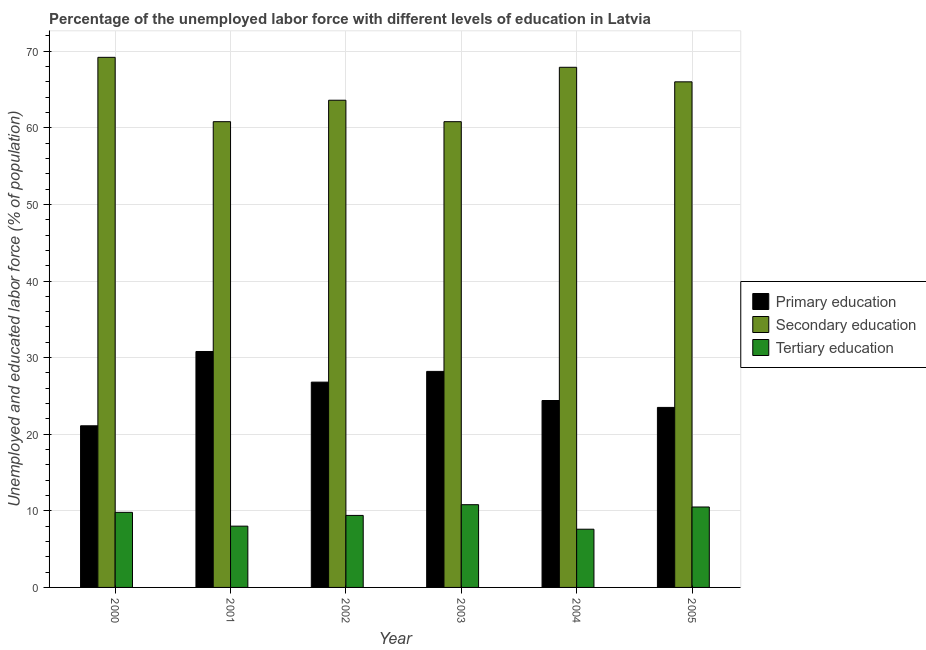How many different coloured bars are there?
Ensure brevity in your answer.  3. How many groups of bars are there?
Offer a very short reply. 6. Are the number of bars per tick equal to the number of legend labels?
Keep it short and to the point. Yes. In how many cases, is the number of bars for a given year not equal to the number of legend labels?
Give a very brief answer. 0. What is the percentage of labor force who received tertiary education in 2004?
Keep it short and to the point. 7.6. Across all years, what is the maximum percentage of labor force who received secondary education?
Your response must be concise. 69.2. Across all years, what is the minimum percentage of labor force who received tertiary education?
Your response must be concise. 7.6. In which year was the percentage of labor force who received primary education minimum?
Keep it short and to the point. 2000. What is the total percentage of labor force who received primary education in the graph?
Offer a terse response. 154.8. What is the difference between the percentage of labor force who received primary education in 2001 and that in 2003?
Provide a succinct answer. 2.6. What is the difference between the percentage of labor force who received primary education in 2000 and the percentage of labor force who received tertiary education in 2005?
Keep it short and to the point. -2.4. What is the average percentage of labor force who received secondary education per year?
Your answer should be very brief. 64.72. In the year 2003, what is the difference between the percentage of labor force who received primary education and percentage of labor force who received tertiary education?
Make the answer very short. 0. In how many years, is the percentage of labor force who received tertiary education greater than 40 %?
Your answer should be very brief. 0. What is the ratio of the percentage of labor force who received primary education in 2000 to that in 2001?
Ensure brevity in your answer.  0.69. Is the percentage of labor force who received primary education in 2001 less than that in 2002?
Offer a terse response. No. What is the difference between the highest and the second highest percentage of labor force who received tertiary education?
Keep it short and to the point. 0.3. What is the difference between the highest and the lowest percentage of labor force who received secondary education?
Provide a short and direct response. 8.4. Is the sum of the percentage of labor force who received tertiary education in 2001 and 2003 greater than the maximum percentage of labor force who received primary education across all years?
Provide a short and direct response. Yes. What does the 3rd bar from the right in 2004 represents?
Make the answer very short. Primary education. How many bars are there?
Provide a succinct answer. 18. How many years are there in the graph?
Provide a short and direct response. 6. Does the graph contain grids?
Your answer should be compact. Yes. How many legend labels are there?
Give a very brief answer. 3. How are the legend labels stacked?
Keep it short and to the point. Vertical. What is the title of the graph?
Your answer should be very brief. Percentage of the unemployed labor force with different levels of education in Latvia. What is the label or title of the X-axis?
Give a very brief answer. Year. What is the label or title of the Y-axis?
Your answer should be very brief. Unemployed and educated labor force (% of population). What is the Unemployed and educated labor force (% of population) in Primary education in 2000?
Offer a terse response. 21.1. What is the Unemployed and educated labor force (% of population) in Secondary education in 2000?
Give a very brief answer. 69.2. What is the Unemployed and educated labor force (% of population) in Tertiary education in 2000?
Your answer should be compact. 9.8. What is the Unemployed and educated labor force (% of population) in Primary education in 2001?
Ensure brevity in your answer.  30.8. What is the Unemployed and educated labor force (% of population) of Secondary education in 2001?
Your answer should be compact. 60.8. What is the Unemployed and educated labor force (% of population) in Tertiary education in 2001?
Your answer should be very brief. 8. What is the Unemployed and educated labor force (% of population) in Primary education in 2002?
Give a very brief answer. 26.8. What is the Unemployed and educated labor force (% of population) in Secondary education in 2002?
Offer a very short reply. 63.6. What is the Unemployed and educated labor force (% of population) in Tertiary education in 2002?
Your response must be concise. 9.4. What is the Unemployed and educated labor force (% of population) of Primary education in 2003?
Your answer should be compact. 28.2. What is the Unemployed and educated labor force (% of population) of Secondary education in 2003?
Offer a terse response. 60.8. What is the Unemployed and educated labor force (% of population) in Tertiary education in 2003?
Give a very brief answer. 10.8. What is the Unemployed and educated labor force (% of population) in Primary education in 2004?
Provide a short and direct response. 24.4. What is the Unemployed and educated labor force (% of population) of Secondary education in 2004?
Provide a succinct answer. 67.9. What is the Unemployed and educated labor force (% of population) in Tertiary education in 2004?
Your answer should be very brief. 7.6. What is the Unemployed and educated labor force (% of population) in Primary education in 2005?
Your response must be concise. 23.5. What is the Unemployed and educated labor force (% of population) in Secondary education in 2005?
Make the answer very short. 66. Across all years, what is the maximum Unemployed and educated labor force (% of population) of Primary education?
Offer a very short reply. 30.8. Across all years, what is the maximum Unemployed and educated labor force (% of population) of Secondary education?
Provide a short and direct response. 69.2. Across all years, what is the maximum Unemployed and educated labor force (% of population) in Tertiary education?
Your answer should be very brief. 10.8. Across all years, what is the minimum Unemployed and educated labor force (% of population) in Primary education?
Your answer should be very brief. 21.1. Across all years, what is the minimum Unemployed and educated labor force (% of population) in Secondary education?
Keep it short and to the point. 60.8. Across all years, what is the minimum Unemployed and educated labor force (% of population) in Tertiary education?
Offer a very short reply. 7.6. What is the total Unemployed and educated labor force (% of population) in Primary education in the graph?
Provide a short and direct response. 154.8. What is the total Unemployed and educated labor force (% of population) in Secondary education in the graph?
Your answer should be compact. 388.3. What is the total Unemployed and educated labor force (% of population) in Tertiary education in the graph?
Offer a terse response. 56.1. What is the difference between the Unemployed and educated labor force (% of population) in Primary education in 2000 and that in 2001?
Ensure brevity in your answer.  -9.7. What is the difference between the Unemployed and educated labor force (% of population) of Secondary education in 2000 and that in 2002?
Your response must be concise. 5.6. What is the difference between the Unemployed and educated labor force (% of population) of Tertiary education in 2000 and that in 2002?
Your answer should be very brief. 0.4. What is the difference between the Unemployed and educated labor force (% of population) in Secondary education in 2000 and that in 2003?
Offer a very short reply. 8.4. What is the difference between the Unemployed and educated labor force (% of population) in Tertiary education in 2000 and that in 2005?
Your response must be concise. -0.7. What is the difference between the Unemployed and educated labor force (% of population) in Primary education in 2001 and that in 2002?
Give a very brief answer. 4. What is the difference between the Unemployed and educated labor force (% of population) of Secondary education in 2001 and that in 2002?
Your response must be concise. -2.8. What is the difference between the Unemployed and educated labor force (% of population) of Tertiary education in 2001 and that in 2002?
Offer a very short reply. -1.4. What is the difference between the Unemployed and educated labor force (% of population) of Primary education in 2001 and that in 2004?
Your response must be concise. 6.4. What is the difference between the Unemployed and educated labor force (% of population) of Secondary education in 2001 and that in 2004?
Ensure brevity in your answer.  -7.1. What is the difference between the Unemployed and educated labor force (% of population) of Tertiary education in 2001 and that in 2004?
Your answer should be very brief. 0.4. What is the difference between the Unemployed and educated labor force (% of population) in Primary education in 2001 and that in 2005?
Offer a terse response. 7.3. What is the difference between the Unemployed and educated labor force (% of population) of Secondary education in 2001 and that in 2005?
Your answer should be compact. -5.2. What is the difference between the Unemployed and educated labor force (% of population) in Primary education in 2002 and that in 2003?
Provide a short and direct response. -1.4. What is the difference between the Unemployed and educated labor force (% of population) of Secondary education in 2002 and that in 2003?
Provide a short and direct response. 2.8. What is the difference between the Unemployed and educated labor force (% of population) of Primary education in 2002 and that in 2004?
Provide a short and direct response. 2.4. What is the difference between the Unemployed and educated labor force (% of population) in Secondary education in 2002 and that in 2004?
Keep it short and to the point. -4.3. What is the difference between the Unemployed and educated labor force (% of population) in Tertiary education in 2002 and that in 2004?
Provide a short and direct response. 1.8. What is the difference between the Unemployed and educated labor force (% of population) of Primary education in 2002 and that in 2005?
Offer a very short reply. 3.3. What is the difference between the Unemployed and educated labor force (% of population) of Tertiary education in 2003 and that in 2004?
Your response must be concise. 3.2. What is the difference between the Unemployed and educated labor force (% of population) of Secondary education in 2003 and that in 2005?
Offer a very short reply. -5.2. What is the difference between the Unemployed and educated labor force (% of population) of Tertiary education in 2003 and that in 2005?
Offer a very short reply. 0.3. What is the difference between the Unemployed and educated labor force (% of population) in Secondary education in 2004 and that in 2005?
Provide a succinct answer. 1.9. What is the difference between the Unemployed and educated labor force (% of population) in Tertiary education in 2004 and that in 2005?
Offer a terse response. -2.9. What is the difference between the Unemployed and educated labor force (% of population) in Primary education in 2000 and the Unemployed and educated labor force (% of population) in Secondary education in 2001?
Your answer should be very brief. -39.7. What is the difference between the Unemployed and educated labor force (% of population) of Primary education in 2000 and the Unemployed and educated labor force (% of population) of Tertiary education in 2001?
Offer a very short reply. 13.1. What is the difference between the Unemployed and educated labor force (% of population) of Secondary education in 2000 and the Unemployed and educated labor force (% of population) of Tertiary education in 2001?
Give a very brief answer. 61.2. What is the difference between the Unemployed and educated labor force (% of population) of Primary education in 2000 and the Unemployed and educated labor force (% of population) of Secondary education in 2002?
Make the answer very short. -42.5. What is the difference between the Unemployed and educated labor force (% of population) in Secondary education in 2000 and the Unemployed and educated labor force (% of population) in Tertiary education in 2002?
Keep it short and to the point. 59.8. What is the difference between the Unemployed and educated labor force (% of population) of Primary education in 2000 and the Unemployed and educated labor force (% of population) of Secondary education in 2003?
Offer a very short reply. -39.7. What is the difference between the Unemployed and educated labor force (% of population) in Secondary education in 2000 and the Unemployed and educated labor force (% of population) in Tertiary education in 2003?
Offer a very short reply. 58.4. What is the difference between the Unemployed and educated labor force (% of population) in Primary education in 2000 and the Unemployed and educated labor force (% of population) in Secondary education in 2004?
Your answer should be very brief. -46.8. What is the difference between the Unemployed and educated labor force (% of population) in Secondary education in 2000 and the Unemployed and educated labor force (% of population) in Tertiary education in 2004?
Offer a terse response. 61.6. What is the difference between the Unemployed and educated labor force (% of population) in Primary education in 2000 and the Unemployed and educated labor force (% of population) in Secondary education in 2005?
Keep it short and to the point. -44.9. What is the difference between the Unemployed and educated labor force (% of population) of Primary education in 2000 and the Unemployed and educated labor force (% of population) of Tertiary education in 2005?
Your answer should be very brief. 10.6. What is the difference between the Unemployed and educated labor force (% of population) of Secondary education in 2000 and the Unemployed and educated labor force (% of population) of Tertiary education in 2005?
Ensure brevity in your answer.  58.7. What is the difference between the Unemployed and educated labor force (% of population) in Primary education in 2001 and the Unemployed and educated labor force (% of population) in Secondary education in 2002?
Offer a terse response. -32.8. What is the difference between the Unemployed and educated labor force (% of population) of Primary education in 2001 and the Unemployed and educated labor force (% of population) of Tertiary education in 2002?
Your answer should be compact. 21.4. What is the difference between the Unemployed and educated labor force (% of population) in Secondary education in 2001 and the Unemployed and educated labor force (% of population) in Tertiary education in 2002?
Keep it short and to the point. 51.4. What is the difference between the Unemployed and educated labor force (% of population) of Primary education in 2001 and the Unemployed and educated labor force (% of population) of Tertiary education in 2003?
Your answer should be very brief. 20. What is the difference between the Unemployed and educated labor force (% of population) in Primary education in 2001 and the Unemployed and educated labor force (% of population) in Secondary education in 2004?
Your answer should be compact. -37.1. What is the difference between the Unemployed and educated labor force (% of population) in Primary education in 2001 and the Unemployed and educated labor force (% of population) in Tertiary education in 2004?
Offer a terse response. 23.2. What is the difference between the Unemployed and educated labor force (% of population) of Secondary education in 2001 and the Unemployed and educated labor force (% of population) of Tertiary education in 2004?
Provide a succinct answer. 53.2. What is the difference between the Unemployed and educated labor force (% of population) of Primary education in 2001 and the Unemployed and educated labor force (% of population) of Secondary education in 2005?
Your response must be concise. -35.2. What is the difference between the Unemployed and educated labor force (% of population) of Primary education in 2001 and the Unemployed and educated labor force (% of population) of Tertiary education in 2005?
Offer a very short reply. 20.3. What is the difference between the Unemployed and educated labor force (% of population) of Secondary education in 2001 and the Unemployed and educated labor force (% of population) of Tertiary education in 2005?
Provide a succinct answer. 50.3. What is the difference between the Unemployed and educated labor force (% of population) of Primary education in 2002 and the Unemployed and educated labor force (% of population) of Secondary education in 2003?
Offer a terse response. -34. What is the difference between the Unemployed and educated labor force (% of population) in Secondary education in 2002 and the Unemployed and educated labor force (% of population) in Tertiary education in 2003?
Provide a succinct answer. 52.8. What is the difference between the Unemployed and educated labor force (% of population) of Primary education in 2002 and the Unemployed and educated labor force (% of population) of Secondary education in 2004?
Ensure brevity in your answer.  -41.1. What is the difference between the Unemployed and educated labor force (% of population) of Primary education in 2002 and the Unemployed and educated labor force (% of population) of Tertiary education in 2004?
Offer a very short reply. 19.2. What is the difference between the Unemployed and educated labor force (% of population) in Secondary education in 2002 and the Unemployed and educated labor force (% of population) in Tertiary education in 2004?
Your answer should be compact. 56. What is the difference between the Unemployed and educated labor force (% of population) of Primary education in 2002 and the Unemployed and educated labor force (% of population) of Secondary education in 2005?
Your answer should be compact. -39.2. What is the difference between the Unemployed and educated labor force (% of population) of Secondary education in 2002 and the Unemployed and educated labor force (% of population) of Tertiary education in 2005?
Give a very brief answer. 53.1. What is the difference between the Unemployed and educated labor force (% of population) of Primary education in 2003 and the Unemployed and educated labor force (% of population) of Secondary education in 2004?
Your response must be concise. -39.7. What is the difference between the Unemployed and educated labor force (% of population) in Primary education in 2003 and the Unemployed and educated labor force (% of population) in Tertiary education in 2004?
Make the answer very short. 20.6. What is the difference between the Unemployed and educated labor force (% of population) of Secondary education in 2003 and the Unemployed and educated labor force (% of population) of Tertiary education in 2004?
Provide a succinct answer. 53.2. What is the difference between the Unemployed and educated labor force (% of population) of Primary education in 2003 and the Unemployed and educated labor force (% of population) of Secondary education in 2005?
Provide a succinct answer. -37.8. What is the difference between the Unemployed and educated labor force (% of population) of Primary education in 2003 and the Unemployed and educated labor force (% of population) of Tertiary education in 2005?
Keep it short and to the point. 17.7. What is the difference between the Unemployed and educated labor force (% of population) of Secondary education in 2003 and the Unemployed and educated labor force (% of population) of Tertiary education in 2005?
Your answer should be very brief. 50.3. What is the difference between the Unemployed and educated labor force (% of population) in Primary education in 2004 and the Unemployed and educated labor force (% of population) in Secondary education in 2005?
Provide a short and direct response. -41.6. What is the difference between the Unemployed and educated labor force (% of population) of Primary education in 2004 and the Unemployed and educated labor force (% of population) of Tertiary education in 2005?
Your response must be concise. 13.9. What is the difference between the Unemployed and educated labor force (% of population) in Secondary education in 2004 and the Unemployed and educated labor force (% of population) in Tertiary education in 2005?
Offer a very short reply. 57.4. What is the average Unemployed and educated labor force (% of population) of Primary education per year?
Offer a terse response. 25.8. What is the average Unemployed and educated labor force (% of population) of Secondary education per year?
Ensure brevity in your answer.  64.72. What is the average Unemployed and educated labor force (% of population) of Tertiary education per year?
Offer a very short reply. 9.35. In the year 2000, what is the difference between the Unemployed and educated labor force (% of population) of Primary education and Unemployed and educated labor force (% of population) of Secondary education?
Provide a succinct answer. -48.1. In the year 2000, what is the difference between the Unemployed and educated labor force (% of population) of Secondary education and Unemployed and educated labor force (% of population) of Tertiary education?
Make the answer very short. 59.4. In the year 2001, what is the difference between the Unemployed and educated labor force (% of population) of Primary education and Unemployed and educated labor force (% of population) of Tertiary education?
Provide a short and direct response. 22.8. In the year 2001, what is the difference between the Unemployed and educated labor force (% of population) of Secondary education and Unemployed and educated labor force (% of population) of Tertiary education?
Provide a short and direct response. 52.8. In the year 2002, what is the difference between the Unemployed and educated labor force (% of population) in Primary education and Unemployed and educated labor force (% of population) in Secondary education?
Offer a very short reply. -36.8. In the year 2002, what is the difference between the Unemployed and educated labor force (% of population) in Secondary education and Unemployed and educated labor force (% of population) in Tertiary education?
Give a very brief answer. 54.2. In the year 2003, what is the difference between the Unemployed and educated labor force (% of population) in Primary education and Unemployed and educated labor force (% of population) in Secondary education?
Offer a very short reply. -32.6. In the year 2003, what is the difference between the Unemployed and educated labor force (% of population) in Primary education and Unemployed and educated labor force (% of population) in Tertiary education?
Your response must be concise. 17.4. In the year 2004, what is the difference between the Unemployed and educated labor force (% of population) in Primary education and Unemployed and educated labor force (% of population) in Secondary education?
Offer a very short reply. -43.5. In the year 2004, what is the difference between the Unemployed and educated labor force (% of population) in Primary education and Unemployed and educated labor force (% of population) in Tertiary education?
Give a very brief answer. 16.8. In the year 2004, what is the difference between the Unemployed and educated labor force (% of population) of Secondary education and Unemployed and educated labor force (% of population) of Tertiary education?
Keep it short and to the point. 60.3. In the year 2005, what is the difference between the Unemployed and educated labor force (% of population) of Primary education and Unemployed and educated labor force (% of population) of Secondary education?
Provide a short and direct response. -42.5. In the year 2005, what is the difference between the Unemployed and educated labor force (% of population) of Secondary education and Unemployed and educated labor force (% of population) of Tertiary education?
Offer a terse response. 55.5. What is the ratio of the Unemployed and educated labor force (% of population) of Primary education in 2000 to that in 2001?
Offer a terse response. 0.69. What is the ratio of the Unemployed and educated labor force (% of population) in Secondary education in 2000 to that in 2001?
Provide a succinct answer. 1.14. What is the ratio of the Unemployed and educated labor force (% of population) of Tertiary education in 2000 to that in 2001?
Provide a short and direct response. 1.23. What is the ratio of the Unemployed and educated labor force (% of population) in Primary education in 2000 to that in 2002?
Give a very brief answer. 0.79. What is the ratio of the Unemployed and educated labor force (% of population) in Secondary education in 2000 to that in 2002?
Give a very brief answer. 1.09. What is the ratio of the Unemployed and educated labor force (% of population) in Tertiary education in 2000 to that in 2002?
Provide a short and direct response. 1.04. What is the ratio of the Unemployed and educated labor force (% of population) in Primary education in 2000 to that in 2003?
Ensure brevity in your answer.  0.75. What is the ratio of the Unemployed and educated labor force (% of population) in Secondary education in 2000 to that in 2003?
Provide a succinct answer. 1.14. What is the ratio of the Unemployed and educated labor force (% of population) of Tertiary education in 2000 to that in 2003?
Your answer should be very brief. 0.91. What is the ratio of the Unemployed and educated labor force (% of population) of Primary education in 2000 to that in 2004?
Keep it short and to the point. 0.86. What is the ratio of the Unemployed and educated labor force (% of population) of Secondary education in 2000 to that in 2004?
Provide a succinct answer. 1.02. What is the ratio of the Unemployed and educated labor force (% of population) in Tertiary education in 2000 to that in 2004?
Your answer should be compact. 1.29. What is the ratio of the Unemployed and educated labor force (% of population) in Primary education in 2000 to that in 2005?
Provide a succinct answer. 0.9. What is the ratio of the Unemployed and educated labor force (% of population) in Secondary education in 2000 to that in 2005?
Offer a very short reply. 1.05. What is the ratio of the Unemployed and educated labor force (% of population) of Primary education in 2001 to that in 2002?
Ensure brevity in your answer.  1.15. What is the ratio of the Unemployed and educated labor force (% of population) in Secondary education in 2001 to that in 2002?
Make the answer very short. 0.96. What is the ratio of the Unemployed and educated labor force (% of population) in Tertiary education in 2001 to that in 2002?
Make the answer very short. 0.85. What is the ratio of the Unemployed and educated labor force (% of population) of Primary education in 2001 to that in 2003?
Offer a terse response. 1.09. What is the ratio of the Unemployed and educated labor force (% of population) of Tertiary education in 2001 to that in 2003?
Make the answer very short. 0.74. What is the ratio of the Unemployed and educated labor force (% of population) of Primary education in 2001 to that in 2004?
Keep it short and to the point. 1.26. What is the ratio of the Unemployed and educated labor force (% of population) of Secondary education in 2001 to that in 2004?
Ensure brevity in your answer.  0.9. What is the ratio of the Unemployed and educated labor force (% of population) of Tertiary education in 2001 to that in 2004?
Provide a succinct answer. 1.05. What is the ratio of the Unemployed and educated labor force (% of population) in Primary education in 2001 to that in 2005?
Offer a very short reply. 1.31. What is the ratio of the Unemployed and educated labor force (% of population) of Secondary education in 2001 to that in 2005?
Give a very brief answer. 0.92. What is the ratio of the Unemployed and educated labor force (% of population) of Tertiary education in 2001 to that in 2005?
Provide a short and direct response. 0.76. What is the ratio of the Unemployed and educated labor force (% of population) in Primary education in 2002 to that in 2003?
Offer a very short reply. 0.95. What is the ratio of the Unemployed and educated labor force (% of population) of Secondary education in 2002 to that in 2003?
Keep it short and to the point. 1.05. What is the ratio of the Unemployed and educated labor force (% of population) of Tertiary education in 2002 to that in 2003?
Make the answer very short. 0.87. What is the ratio of the Unemployed and educated labor force (% of population) of Primary education in 2002 to that in 2004?
Keep it short and to the point. 1.1. What is the ratio of the Unemployed and educated labor force (% of population) of Secondary education in 2002 to that in 2004?
Ensure brevity in your answer.  0.94. What is the ratio of the Unemployed and educated labor force (% of population) of Tertiary education in 2002 to that in 2004?
Offer a very short reply. 1.24. What is the ratio of the Unemployed and educated labor force (% of population) in Primary education in 2002 to that in 2005?
Your answer should be very brief. 1.14. What is the ratio of the Unemployed and educated labor force (% of population) of Secondary education in 2002 to that in 2005?
Offer a terse response. 0.96. What is the ratio of the Unemployed and educated labor force (% of population) of Tertiary education in 2002 to that in 2005?
Offer a very short reply. 0.9. What is the ratio of the Unemployed and educated labor force (% of population) of Primary education in 2003 to that in 2004?
Keep it short and to the point. 1.16. What is the ratio of the Unemployed and educated labor force (% of population) of Secondary education in 2003 to that in 2004?
Provide a succinct answer. 0.9. What is the ratio of the Unemployed and educated labor force (% of population) in Tertiary education in 2003 to that in 2004?
Offer a terse response. 1.42. What is the ratio of the Unemployed and educated labor force (% of population) in Secondary education in 2003 to that in 2005?
Offer a very short reply. 0.92. What is the ratio of the Unemployed and educated labor force (% of population) in Tertiary education in 2003 to that in 2005?
Make the answer very short. 1.03. What is the ratio of the Unemployed and educated labor force (% of population) of Primary education in 2004 to that in 2005?
Keep it short and to the point. 1.04. What is the ratio of the Unemployed and educated labor force (% of population) of Secondary education in 2004 to that in 2005?
Provide a succinct answer. 1.03. What is the ratio of the Unemployed and educated labor force (% of population) in Tertiary education in 2004 to that in 2005?
Make the answer very short. 0.72. What is the difference between the highest and the second highest Unemployed and educated labor force (% of population) in Primary education?
Give a very brief answer. 2.6. What is the difference between the highest and the second highest Unemployed and educated labor force (% of population) in Secondary education?
Give a very brief answer. 1.3. What is the difference between the highest and the lowest Unemployed and educated labor force (% of population) in Secondary education?
Give a very brief answer. 8.4. What is the difference between the highest and the lowest Unemployed and educated labor force (% of population) in Tertiary education?
Your response must be concise. 3.2. 